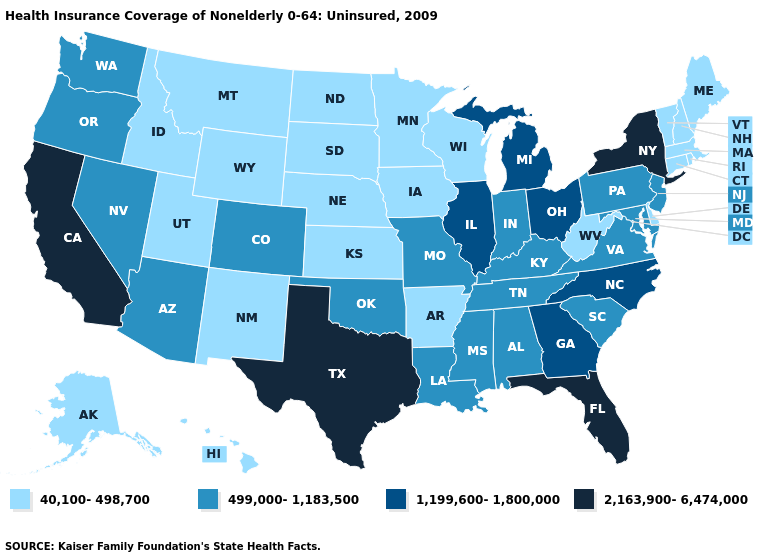Name the states that have a value in the range 1,199,600-1,800,000?
Concise answer only. Georgia, Illinois, Michigan, North Carolina, Ohio. Which states hav the highest value in the Northeast?
Short answer required. New York. Name the states that have a value in the range 1,199,600-1,800,000?
Write a very short answer. Georgia, Illinois, Michigan, North Carolina, Ohio. Name the states that have a value in the range 40,100-498,700?
Be succinct. Alaska, Arkansas, Connecticut, Delaware, Hawaii, Idaho, Iowa, Kansas, Maine, Massachusetts, Minnesota, Montana, Nebraska, New Hampshire, New Mexico, North Dakota, Rhode Island, South Dakota, Utah, Vermont, West Virginia, Wisconsin, Wyoming. Name the states that have a value in the range 40,100-498,700?
Concise answer only. Alaska, Arkansas, Connecticut, Delaware, Hawaii, Idaho, Iowa, Kansas, Maine, Massachusetts, Minnesota, Montana, Nebraska, New Hampshire, New Mexico, North Dakota, Rhode Island, South Dakota, Utah, Vermont, West Virginia, Wisconsin, Wyoming. What is the value of Massachusetts?
Be succinct. 40,100-498,700. Does South Dakota have the same value as Connecticut?
Keep it brief. Yes. Name the states that have a value in the range 2,163,900-6,474,000?
Write a very short answer. California, Florida, New York, Texas. Name the states that have a value in the range 1,199,600-1,800,000?
Answer briefly. Georgia, Illinois, Michigan, North Carolina, Ohio. What is the value of Nevada?
Short answer required. 499,000-1,183,500. Which states have the lowest value in the USA?
Give a very brief answer. Alaska, Arkansas, Connecticut, Delaware, Hawaii, Idaho, Iowa, Kansas, Maine, Massachusetts, Minnesota, Montana, Nebraska, New Hampshire, New Mexico, North Dakota, Rhode Island, South Dakota, Utah, Vermont, West Virginia, Wisconsin, Wyoming. Name the states that have a value in the range 40,100-498,700?
Short answer required. Alaska, Arkansas, Connecticut, Delaware, Hawaii, Idaho, Iowa, Kansas, Maine, Massachusetts, Minnesota, Montana, Nebraska, New Hampshire, New Mexico, North Dakota, Rhode Island, South Dakota, Utah, Vermont, West Virginia, Wisconsin, Wyoming. Which states have the lowest value in the MidWest?
Short answer required. Iowa, Kansas, Minnesota, Nebraska, North Dakota, South Dakota, Wisconsin. Name the states that have a value in the range 2,163,900-6,474,000?
Write a very short answer. California, Florida, New York, Texas. 